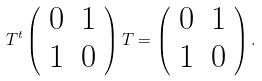<formula> <loc_0><loc_0><loc_500><loc_500>T ^ { t } \left ( \begin{array} { c c } { 0 } & { 1 } \\ { 1 } & { 0 } \end{array} \right ) T = \left ( \begin{array} { c c } { 0 } & { 1 } \\ { 1 } & { 0 } \end{array} \right ) .</formula> 